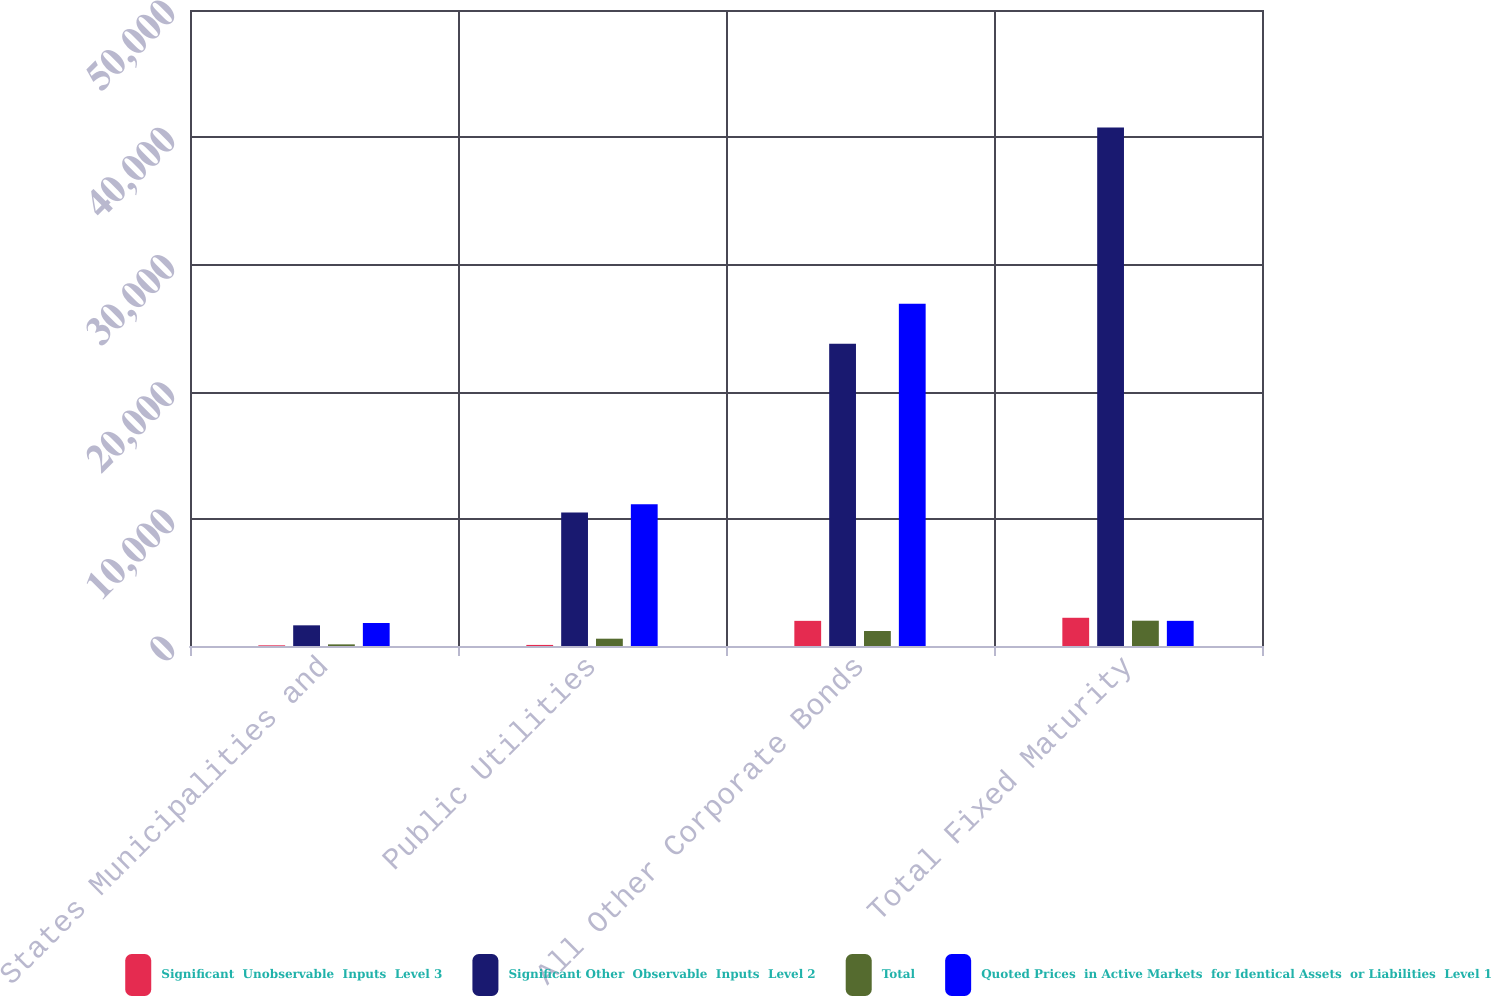Convert chart. <chart><loc_0><loc_0><loc_500><loc_500><stacked_bar_chart><ecel><fcel>States Municipalities and<fcel>Public Utilities<fcel>All Other Corporate Bonds<fcel>Total Fixed Maturity<nl><fcel>Significant  Unobservable  Inputs  Level 3<fcel>53<fcel>84.2<fcel>1977.1<fcel>2218.4<nl><fcel>Significant Other  Observable  Inputs  Level 2<fcel>1625.1<fcel>10485.6<fcel>23755.5<fcel>40766.3<nl><fcel>Total<fcel>128.7<fcel>574.4<fcel>1177.8<fcel>1988.3<nl><fcel>Quoted Prices  in Active Markets  for Identical Assets  or Liabilities  Level 1<fcel>1806.8<fcel>11144.2<fcel>26910.4<fcel>1977.1<nl></chart> 